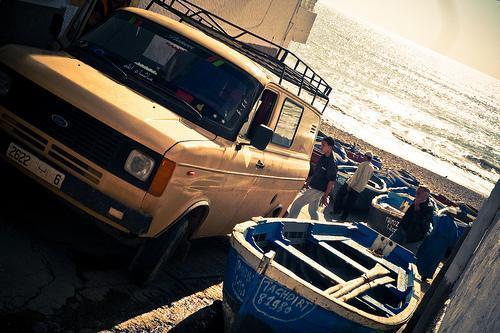How many people are there?
Give a very brief answer. 4. How many cars are there?
Give a very brief answer. 1. 